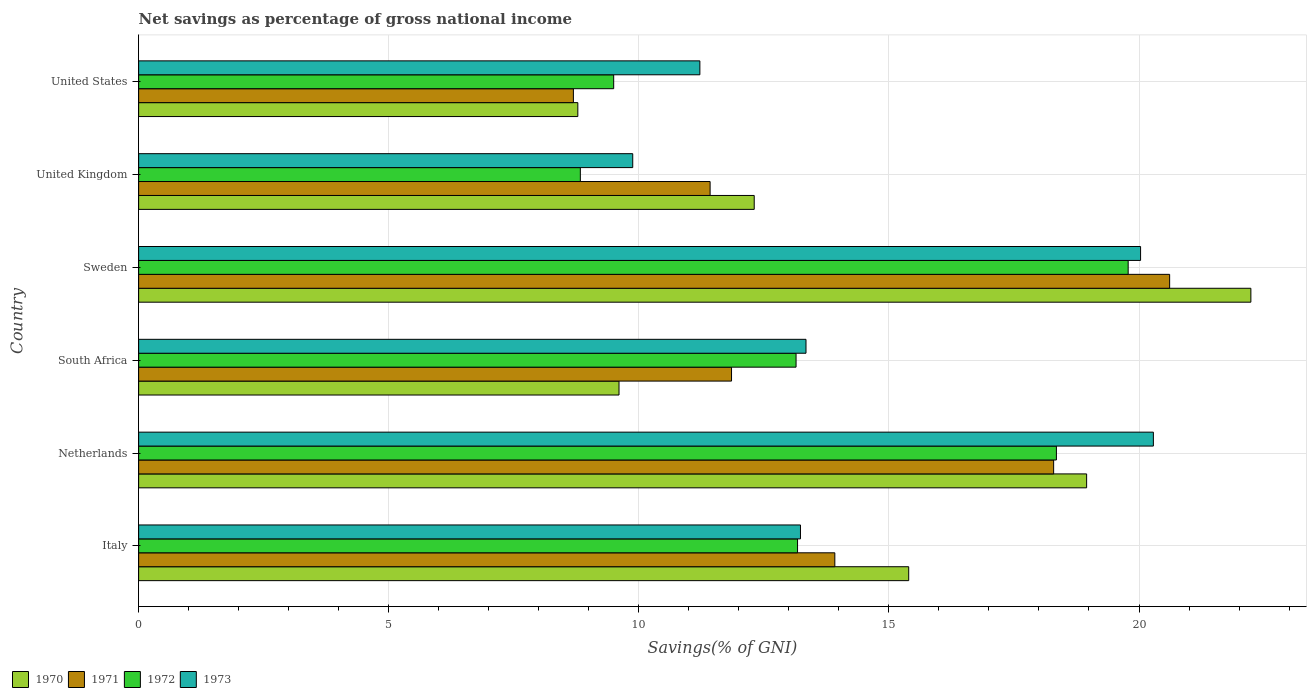How many different coloured bars are there?
Provide a short and direct response. 4. How many groups of bars are there?
Your answer should be compact. 6. Are the number of bars per tick equal to the number of legend labels?
Give a very brief answer. Yes. How many bars are there on the 6th tick from the bottom?
Make the answer very short. 4. What is the label of the 1st group of bars from the top?
Your answer should be compact. United States. In how many cases, is the number of bars for a given country not equal to the number of legend labels?
Make the answer very short. 0. What is the total savings in 1972 in United States?
Your answer should be very brief. 9.5. Across all countries, what is the maximum total savings in 1970?
Your answer should be very brief. 22.24. Across all countries, what is the minimum total savings in 1971?
Provide a short and direct response. 8.69. In which country was the total savings in 1971 maximum?
Your response must be concise. Sweden. What is the total total savings in 1971 in the graph?
Provide a succinct answer. 84.8. What is the difference between the total savings in 1971 in Netherlands and that in United States?
Make the answer very short. 9.6. What is the difference between the total savings in 1973 in United States and the total savings in 1972 in United Kingdom?
Provide a short and direct response. 2.39. What is the average total savings in 1971 per country?
Your answer should be compact. 14.13. What is the difference between the total savings in 1971 and total savings in 1972 in South Africa?
Your answer should be very brief. -1.29. What is the ratio of the total savings in 1971 in Sweden to that in United States?
Your answer should be very brief. 2.37. Is the difference between the total savings in 1971 in South Africa and United Kingdom greater than the difference between the total savings in 1972 in South Africa and United Kingdom?
Your answer should be compact. No. What is the difference between the highest and the second highest total savings in 1971?
Your answer should be compact. 2.32. What is the difference between the highest and the lowest total savings in 1972?
Offer a very short reply. 10.95. In how many countries, is the total savings in 1971 greater than the average total savings in 1971 taken over all countries?
Ensure brevity in your answer.  2. Is it the case that in every country, the sum of the total savings in 1970 and total savings in 1972 is greater than the sum of total savings in 1971 and total savings in 1973?
Your answer should be compact. No. What does the 2nd bar from the top in Italy represents?
Offer a very short reply. 1972. How many bars are there?
Provide a short and direct response. 24. Are the values on the major ticks of X-axis written in scientific E-notation?
Offer a terse response. No. Where does the legend appear in the graph?
Make the answer very short. Bottom left. How many legend labels are there?
Your answer should be very brief. 4. How are the legend labels stacked?
Your answer should be compact. Horizontal. What is the title of the graph?
Your response must be concise. Net savings as percentage of gross national income. Does "1961" appear as one of the legend labels in the graph?
Provide a succinct answer. No. What is the label or title of the X-axis?
Ensure brevity in your answer.  Savings(% of GNI). What is the Savings(% of GNI) of 1970 in Italy?
Offer a very short reply. 15.4. What is the Savings(% of GNI) in 1971 in Italy?
Your answer should be compact. 13.92. What is the Savings(% of GNI) in 1972 in Italy?
Offer a terse response. 13.17. What is the Savings(% of GNI) in 1973 in Italy?
Keep it short and to the point. 13.23. What is the Savings(% of GNI) of 1970 in Netherlands?
Your answer should be compact. 18.95. What is the Savings(% of GNI) of 1971 in Netherlands?
Ensure brevity in your answer.  18.29. What is the Savings(% of GNI) of 1972 in Netherlands?
Your answer should be compact. 18.35. What is the Savings(% of GNI) in 1973 in Netherlands?
Your answer should be very brief. 20.29. What is the Savings(% of GNI) of 1970 in South Africa?
Your answer should be very brief. 9.6. What is the Savings(% of GNI) of 1971 in South Africa?
Ensure brevity in your answer.  11.85. What is the Savings(% of GNI) in 1972 in South Africa?
Offer a terse response. 13.14. What is the Savings(% of GNI) in 1973 in South Africa?
Your response must be concise. 13.34. What is the Savings(% of GNI) of 1970 in Sweden?
Provide a short and direct response. 22.24. What is the Savings(% of GNI) in 1971 in Sweden?
Your answer should be compact. 20.61. What is the Savings(% of GNI) in 1972 in Sweden?
Your answer should be compact. 19.78. What is the Savings(% of GNI) of 1973 in Sweden?
Make the answer very short. 20.03. What is the Savings(% of GNI) in 1970 in United Kingdom?
Provide a succinct answer. 12.31. What is the Savings(% of GNI) in 1971 in United Kingdom?
Your answer should be compact. 11.43. What is the Savings(% of GNI) in 1972 in United Kingdom?
Your response must be concise. 8.83. What is the Savings(% of GNI) of 1973 in United Kingdom?
Ensure brevity in your answer.  9.88. What is the Savings(% of GNI) of 1970 in United States?
Ensure brevity in your answer.  8.78. What is the Savings(% of GNI) in 1971 in United States?
Your answer should be compact. 8.69. What is the Savings(% of GNI) in 1972 in United States?
Your response must be concise. 9.5. What is the Savings(% of GNI) in 1973 in United States?
Provide a succinct answer. 11.22. Across all countries, what is the maximum Savings(% of GNI) of 1970?
Your answer should be compact. 22.24. Across all countries, what is the maximum Savings(% of GNI) of 1971?
Provide a succinct answer. 20.61. Across all countries, what is the maximum Savings(% of GNI) in 1972?
Ensure brevity in your answer.  19.78. Across all countries, what is the maximum Savings(% of GNI) in 1973?
Your response must be concise. 20.29. Across all countries, what is the minimum Savings(% of GNI) of 1970?
Your answer should be compact. 8.78. Across all countries, what is the minimum Savings(% of GNI) in 1971?
Give a very brief answer. 8.69. Across all countries, what is the minimum Savings(% of GNI) of 1972?
Your answer should be very brief. 8.83. Across all countries, what is the minimum Savings(% of GNI) of 1973?
Ensure brevity in your answer.  9.88. What is the total Savings(% of GNI) of 1970 in the graph?
Your answer should be very brief. 87.28. What is the total Savings(% of GNI) in 1971 in the graph?
Keep it short and to the point. 84.8. What is the total Savings(% of GNI) in 1972 in the graph?
Your response must be concise. 82.78. What is the total Savings(% of GNI) of 1973 in the graph?
Your answer should be compact. 87.99. What is the difference between the Savings(% of GNI) of 1970 in Italy and that in Netherlands?
Offer a very short reply. -3.56. What is the difference between the Savings(% of GNI) of 1971 in Italy and that in Netherlands?
Give a very brief answer. -4.37. What is the difference between the Savings(% of GNI) of 1972 in Italy and that in Netherlands?
Provide a succinct answer. -5.18. What is the difference between the Savings(% of GNI) in 1973 in Italy and that in Netherlands?
Your answer should be compact. -7.06. What is the difference between the Savings(% of GNI) of 1970 in Italy and that in South Africa?
Provide a short and direct response. 5.79. What is the difference between the Savings(% of GNI) in 1971 in Italy and that in South Africa?
Give a very brief answer. 2.07. What is the difference between the Savings(% of GNI) in 1972 in Italy and that in South Africa?
Your answer should be compact. 0.03. What is the difference between the Savings(% of GNI) in 1973 in Italy and that in South Africa?
Provide a short and direct response. -0.11. What is the difference between the Savings(% of GNI) in 1970 in Italy and that in Sweden?
Ensure brevity in your answer.  -6.84. What is the difference between the Savings(% of GNI) in 1971 in Italy and that in Sweden?
Your answer should be compact. -6.69. What is the difference between the Savings(% of GNI) of 1972 in Italy and that in Sweden?
Offer a very short reply. -6.61. What is the difference between the Savings(% of GNI) in 1973 in Italy and that in Sweden?
Make the answer very short. -6.8. What is the difference between the Savings(% of GNI) of 1970 in Italy and that in United Kingdom?
Keep it short and to the point. 3.09. What is the difference between the Savings(% of GNI) in 1971 in Italy and that in United Kingdom?
Your response must be concise. 2.49. What is the difference between the Savings(% of GNI) of 1972 in Italy and that in United Kingdom?
Your answer should be compact. 4.34. What is the difference between the Savings(% of GNI) in 1973 in Italy and that in United Kingdom?
Offer a very short reply. 3.35. What is the difference between the Savings(% of GNI) of 1970 in Italy and that in United States?
Offer a terse response. 6.62. What is the difference between the Savings(% of GNI) in 1971 in Italy and that in United States?
Make the answer very short. 5.23. What is the difference between the Savings(% of GNI) of 1972 in Italy and that in United States?
Ensure brevity in your answer.  3.68. What is the difference between the Savings(% of GNI) of 1973 in Italy and that in United States?
Your answer should be very brief. 2.01. What is the difference between the Savings(% of GNI) of 1970 in Netherlands and that in South Africa?
Ensure brevity in your answer.  9.35. What is the difference between the Savings(% of GNI) in 1971 in Netherlands and that in South Africa?
Keep it short and to the point. 6.44. What is the difference between the Savings(% of GNI) of 1972 in Netherlands and that in South Africa?
Provide a short and direct response. 5.21. What is the difference between the Savings(% of GNI) of 1973 in Netherlands and that in South Africa?
Your response must be concise. 6.95. What is the difference between the Savings(% of GNI) of 1970 in Netherlands and that in Sweden?
Ensure brevity in your answer.  -3.28. What is the difference between the Savings(% of GNI) in 1971 in Netherlands and that in Sweden?
Keep it short and to the point. -2.32. What is the difference between the Savings(% of GNI) of 1972 in Netherlands and that in Sweden?
Your answer should be very brief. -1.43. What is the difference between the Savings(% of GNI) of 1973 in Netherlands and that in Sweden?
Offer a very short reply. 0.26. What is the difference between the Savings(% of GNI) in 1970 in Netherlands and that in United Kingdom?
Provide a succinct answer. 6.65. What is the difference between the Savings(% of GNI) of 1971 in Netherlands and that in United Kingdom?
Give a very brief answer. 6.87. What is the difference between the Savings(% of GNI) of 1972 in Netherlands and that in United Kingdom?
Your answer should be very brief. 9.52. What is the difference between the Savings(% of GNI) of 1973 in Netherlands and that in United Kingdom?
Make the answer very short. 10.41. What is the difference between the Savings(% of GNI) of 1970 in Netherlands and that in United States?
Give a very brief answer. 10.17. What is the difference between the Savings(% of GNI) in 1971 in Netherlands and that in United States?
Provide a succinct answer. 9.6. What is the difference between the Savings(% of GNI) in 1972 in Netherlands and that in United States?
Ensure brevity in your answer.  8.85. What is the difference between the Savings(% of GNI) in 1973 in Netherlands and that in United States?
Your answer should be compact. 9.07. What is the difference between the Savings(% of GNI) of 1970 in South Africa and that in Sweden?
Keep it short and to the point. -12.63. What is the difference between the Savings(% of GNI) of 1971 in South Africa and that in Sweden?
Provide a short and direct response. -8.76. What is the difference between the Savings(% of GNI) in 1972 in South Africa and that in Sweden?
Your answer should be compact. -6.64. What is the difference between the Savings(% of GNI) of 1973 in South Africa and that in Sweden?
Your response must be concise. -6.69. What is the difference between the Savings(% of GNI) of 1970 in South Africa and that in United Kingdom?
Offer a very short reply. -2.7. What is the difference between the Savings(% of GNI) in 1971 in South Africa and that in United Kingdom?
Your answer should be very brief. 0.43. What is the difference between the Savings(% of GNI) in 1972 in South Africa and that in United Kingdom?
Keep it short and to the point. 4.31. What is the difference between the Savings(% of GNI) of 1973 in South Africa and that in United Kingdom?
Your answer should be compact. 3.46. What is the difference between the Savings(% of GNI) in 1970 in South Africa and that in United States?
Your response must be concise. 0.82. What is the difference between the Savings(% of GNI) of 1971 in South Africa and that in United States?
Offer a very short reply. 3.16. What is the difference between the Savings(% of GNI) in 1972 in South Africa and that in United States?
Your answer should be very brief. 3.65. What is the difference between the Savings(% of GNI) in 1973 in South Africa and that in United States?
Your response must be concise. 2.12. What is the difference between the Savings(% of GNI) of 1970 in Sweden and that in United Kingdom?
Your answer should be compact. 9.93. What is the difference between the Savings(% of GNI) in 1971 in Sweden and that in United Kingdom?
Provide a short and direct response. 9.19. What is the difference between the Savings(% of GNI) of 1972 in Sweden and that in United Kingdom?
Your answer should be very brief. 10.95. What is the difference between the Savings(% of GNI) of 1973 in Sweden and that in United Kingdom?
Your answer should be compact. 10.15. What is the difference between the Savings(% of GNI) of 1970 in Sweden and that in United States?
Ensure brevity in your answer.  13.46. What is the difference between the Savings(% of GNI) in 1971 in Sweden and that in United States?
Provide a short and direct response. 11.92. What is the difference between the Savings(% of GNI) in 1972 in Sweden and that in United States?
Provide a short and direct response. 10.29. What is the difference between the Savings(% of GNI) of 1973 in Sweden and that in United States?
Offer a terse response. 8.81. What is the difference between the Savings(% of GNI) in 1970 in United Kingdom and that in United States?
Make the answer very short. 3.53. What is the difference between the Savings(% of GNI) in 1971 in United Kingdom and that in United States?
Give a very brief answer. 2.73. What is the difference between the Savings(% of GNI) in 1972 in United Kingdom and that in United States?
Provide a short and direct response. -0.67. What is the difference between the Savings(% of GNI) in 1973 in United Kingdom and that in United States?
Make the answer very short. -1.34. What is the difference between the Savings(% of GNI) in 1970 in Italy and the Savings(% of GNI) in 1971 in Netherlands?
Provide a succinct answer. -2.9. What is the difference between the Savings(% of GNI) of 1970 in Italy and the Savings(% of GNI) of 1972 in Netherlands?
Ensure brevity in your answer.  -2.95. What is the difference between the Savings(% of GNI) of 1970 in Italy and the Savings(% of GNI) of 1973 in Netherlands?
Give a very brief answer. -4.89. What is the difference between the Savings(% of GNI) in 1971 in Italy and the Savings(% of GNI) in 1972 in Netherlands?
Provide a succinct answer. -4.43. What is the difference between the Savings(% of GNI) of 1971 in Italy and the Savings(% of GNI) of 1973 in Netherlands?
Your answer should be compact. -6.37. What is the difference between the Savings(% of GNI) of 1972 in Italy and the Savings(% of GNI) of 1973 in Netherlands?
Your answer should be very brief. -7.11. What is the difference between the Savings(% of GNI) in 1970 in Italy and the Savings(% of GNI) in 1971 in South Africa?
Provide a short and direct response. 3.54. What is the difference between the Savings(% of GNI) of 1970 in Italy and the Savings(% of GNI) of 1972 in South Africa?
Offer a very short reply. 2.25. What is the difference between the Savings(% of GNI) of 1970 in Italy and the Savings(% of GNI) of 1973 in South Africa?
Provide a short and direct response. 2.05. What is the difference between the Savings(% of GNI) of 1971 in Italy and the Savings(% of GNI) of 1972 in South Africa?
Offer a very short reply. 0.78. What is the difference between the Savings(% of GNI) of 1971 in Italy and the Savings(% of GNI) of 1973 in South Africa?
Offer a very short reply. 0.58. What is the difference between the Savings(% of GNI) in 1972 in Italy and the Savings(% of GNI) in 1973 in South Africa?
Make the answer very short. -0.17. What is the difference between the Savings(% of GNI) in 1970 in Italy and the Savings(% of GNI) in 1971 in Sweden?
Offer a very short reply. -5.22. What is the difference between the Savings(% of GNI) in 1970 in Italy and the Savings(% of GNI) in 1972 in Sweden?
Your answer should be compact. -4.39. What is the difference between the Savings(% of GNI) in 1970 in Italy and the Savings(% of GNI) in 1973 in Sweden?
Make the answer very short. -4.64. What is the difference between the Savings(% of GNI) in 1971 in Italy and the Savings(% of GNI) in 1972 in Sweden?
Offer a terse response. -5.86. What is the difference between the Savings(% of GNI) in 1971 in Italy and the Savings(% of GNI) in 1973 in Sweden?
Your answer should be compact. -6.11. What is the difference between the Savings(% of GNI) in 1972 in Italy and the Savings(% of GNI) in 1973 in Sweden?
Keep it short and to the point. -6.86. What is the difference between the Savings(% of GNI) of 1970 in Italy and the Savings(% of GNI) of 1971 in United Kingdom?
Offer a very short reply. 3.97. What is the difference between the Savings(% of GNI) in 1970 in Italy and the Savings(% of GNI) in 1972 in United Kingdom?
Ensure brevity in your answer.  6.56. What is the difference between the Savings(% of GNI) of 1970 in Italy and the Savings(% of GNI) of 1973 in United Kingdom?
Provide a short and direct response. 5.52. What is the difference between the Savings(% of GNI) of 1971 in Italy and the Savings(% of GNI) of 1972 in United Kingdom?
Your response must be concise. 5.09. What is the difference between the Savings(% of GNI) in 1971 in Italy and the Savings(% of GNI) in 1973 in United Kingdom?
Your answer should be compact. 4.04. What is the difference between the Savings(% of GNI) in 1972 in Italy and the Savings(% of GNI) in 1973 in United Kingdom?
Offer a very short reply. 3.3. What is the difference between the Savings(% of GNI) in 1970 in Italy and the Savings(% of GNI) in 1971 in United States?
Your response must be concise. 6.7. What is the difference between the Savings(% of GNI) of 1970 in Italy and the Savings(% of GNI) of 1972 in United States?
Provide a succinct answer. 5.9. What is the difference between the Savings(% of GNI) in 1970 in Italy and the Savings(% of GNI) in 1973 in United States?
Give a very brief answer. 4.17. What is the difference between the Savings(% of GNI) in 1971 in Italy and the Savings(% of GNI) in 1972 in United States?
Your response must be concise. 4.42. What is the difference between the Savings(% of GNI) of 1971 in Italy and the Savings(% of GNI) of 1973 in United States?
Your response must be concise. 2.7. What is the difference between the Savings(% of GNI) in 1972 in Italy and the Savings(% of GNI) in 1973 in United States?
Offer a very short reply. 1.95. What is the difference between the Savings(% of GNI) of 1970 in Netherlands and the Savings(% of GNI) of 1971 in South Africa?
Ensure brevity in your answer.  7.1. What is the difference between the Savings(% of GNI) of 1970 in Netherlands and the Savings(% of GNI) of 1972 in South Africa?
Give a very brief answer. 5.81. What is the difference between the Savings(% of GNI) in 1970 in Netherlands and the Savings(% of GNI) in 1973 in South Africa?
Keep it short and to the point. 5.61. What is the difference between the Savings(% of GNI) of 1971 in Netherlands and the Savings(% of GNI) of 1972 in South Africa?
Make the answer very short. 5.15. What is the difference between the Savings(% of GNI) of 1971 in Netherlands and the Savings(% of GNI) of 1973 in South Africa?
Ensure brevity in your answer.  4.95. What is the difference between the Savings(% of GNI) in 1972 in Netherlands and the Savings(% of GNI) in 1973 in South Africa?
Your answer should be very brief. 5.01. What is the difference between the Savings(% of GNI) of 1970 in Netherlands and the Savings(% of GNI) of 1971 in Sweden?
Give a very brief answer. -1.66. What is the difference between the Savings(% of GNI) in 1970 in Netherlands and the Savings(% of GNI) in 1972 in Sweden?
Offer a terse response. -0.83. What is the difference between the Savings(% of GNI) of 1970 in Netherlands and the Savings(% of GNI) of 1973 in Sweden?
Give a very brief answer. -1.08. What is the difference between the Savings(% of GNI) of 1971 in Netherlands and the Savings(% of GNI) of 1972 in Sweden?
Offer a very short reply. -1.49. What is the difference between the Savings(% of GNI) in 1971 in Netherlands and the Savings(% of GNI) in 1973 in Sweden?
Offer a terse response. -1.74. What is the difference between the Savings(% of GNI) in 1972 in Netherlands and the Savings(% of GNI) in 1973 in Sweden?
Your answer should be compact. -1.68. What is the difference between the Savings(% of GNI) of 1970 in Netherlands and the Savings(% of GNI) of 1971 in United Kingdom?
Make the answer very short. 7.53. What is the difference between the Savings(% of GNI) of 1970 in Netherlands and the Savings(% of GNI) of 1972 in United Kingdom?
Provide a short and direct response. 10.12. What is the difference between the Savings(% of GNI) in 1970 in Netherlands and the Savings(% of GNI) in 1973 in United Kingdom?
Your answer should be very brief. 9.07. What is the difference between the Savings(% of GNI) in 1971 in Netherlands and the Savings(% of GNI) in 1972 in United Kingdom?
Make the answer very short. 9.46. What is the difference between the Savings(% of GNI) in 1971 in Netherlands and the Savings(% of GNI) in 1973 in United Kingdom?
Your answer should be compact. 8.42. What is the difference between the Savings(% of GNI) of 1972 in Netherlands and the Savings(% of GNI) of 1973 in United Kingdom?
Your response must be concise. 8.47. What is the difference between the Savings(% of GNI) of 1970 in Netherlands and the Savings(% of GNI) of 1971 in United States?
Your answer should be compact. 10.26. What is the difference between the Savings(% of GNI) in 1970 in Netherlands and the Savings(% of GNI) in 1972 in United States?
Your answer should be very brief. 9.46. What is the difference between the Savings(% of GNI) in 1970 in Netherlands and the Savings(% of GNI) in 1973 in United States?
Ensure brevity in your answer.  7.73. What is the difference between the Savings(% of GNI) of 1971 in Netherlands and the Savings(% of GNI) of 1972 in United States?
Make the answer very short. 8.8. What is the difference between the Savings(% of GNI) in 1971 in Netherlands and the Savings(% of GNI) in 1973 in United States?
Give a very brief answer. 7.07. What is the difference between the Savings(% of GNI) in 1972 in Netherlands and the Savings(% of GNI) in 1973 in United States?
Your answer should be very brief. 7.13. What is the difference between the Savings(% of GNI) in 1970 in South Africa and the Savings(% of GNI) in 1971 in Sweden?
Ensure brevity in your answer.  -11.01. What is the difference between the Savings(% of GNI) in 1970 in South Africa and the Savings(% of GNI) in 1972 in Sweden?
Keep it short and to the point. -10.18. What is the difference between the Savings(% of GNI) of 1970 in South Africa and the Savings(% of GNI) of 1973 in Sweden?
Ensure brevity in your answer.  -10.43. What is the difference between the Savings(% of GNI) in 1971 in South Africa and the Savings(% of GNI) in 1972 in Sweden?
Provide a short and direct response. -7.93. What is the difference between the Savings(% of GNI) of 1971 in South Africa and the Savings(% of GNI) of 1973 in Sweden?
Your answer should be compact. -8.18. What is the difference between the Savings(% of GNI) of 1972 in South Africa and the Savings(% of GNI) of 1973 in Sweden?
Your answer should be very brief. -6.89. What is the difference between the Savings(% of GNI) in 1970 in South Africa and the Savings(% of GNI) in 1971 in United Kingdom?
Provide a succinct answer. -1.82. What is the difference between the Savings(% of GNI) in 1970 in South Africa and the Savings(% of GNI) in 1972 in United Kingdom?
Offer a terse response. 0.77. What is the difference between the Savings(% of GNI) in 1970 in South Africa and the Savings(% of GNI) in 1973 in United Kingdom?
Provide a short and direct response. -0.27. What is the difference between the Savings(% of GNI) of 1971 in South Africa and the Savings(% of GNI) of 1972 in United Kingdom?
Keep it short and to the point. 3.02. What is the difference between the Savings(% of GNI) of 1971 in South Africa and the Savings(% of GNI) of 1973 in United Kingdom?
Your answer should be compact. 1.98. What is the difference between the Savings(% of GNI) in 1972 in South Africa and the Savings(% of GNI) in 1973 in United Kingdom?
Ensure brevity in your answer.  3.27. What is the difference between the Savings(% of GNI) in 1970 in South Africa and the Savings(% of GNI) in 1971 in United States?
Ensure brevity in your answer.  0.91. What is the difference between the Savings(% of GNI) of 1970 in South Africa and the Savings(% of GNI) of 1972 in United States?
Offer a terse response. 0.11. What is the difference between the Savings(% of GNI) in 1970 in South Africa and the Savings(% of GNI) in 1973 in United States?
Provide a short and direct response. -1.62. What is the difference between the Savings(% of GNI) in 1971 in South Africa and the Savings(% of GNI) in 1972 in United States?
Your answer should be very brief. 2.36. What is the difference between the Savings(% of GNI) of 1971 in South Africa and the Savings(% of GNI) of 1973 in United States?
Offer a terse response. 0.63. What is the difference between the Savings(% of GNI) of 1972 in South Africa and the Savings(% of GNI) of 1973 in United States?
Offer a terse response. 1.92. What is the difference between the Savings(% of GNI) in 1970 in Sweden and the Savings(% of GNI) in 1971 in United Kingdom?
Ensure brevity in your answer.  10.81. What is the difference between the Savings(% of GNI) of 1970 in Sweden and the Savings(% of GNI) of 1972 in United Kingdom?
Give a very brief answer. 13.41. What is the difference between the Savings(% of GNI) in 1970 in Sweden and the Savings(% of GNI) in 1973 in United Kingdom?
Provide a succinct answer. 12.36. What is the difference between the Savings(% of GNI) of 1971 in Sweden and the Savings(% of GNI) of 1972 in United Kingdom?
Your answer should be compact. 11.78. What is the difference between the Savings(% of GNI) of 1971 in Sweden and the Savings(% of GNI) of 1973 in United Kingdom?
Provide a short and direct response. 10.73. What is the difference between the Savings(% of GNI) of 1972 in Sweden and the Savings(% of GNI) of 1973 in United Kingdom?
Your answer should be compact. 9.91. What is the difference between the Savings(% of GNI) in 1970 in Sweden and the Savings(% of GNI) in 1971 in United States?
Ensure brevity in your answer.  13.54. What is the difference between the Savings(% of GNI) of 1970 in Sweden and the Savings(% of GNI) of 1972 in United States?
Ensure brevity in your answer.  12.74. What is the difference between the Savings(% of GNI) in 1970 in Sweden and the Savings(% of GNI) in 1973 in United States?
Ensure brevity in your answer.  11.02. What is the difference between the Savings(% of GNI) of 1971 in Sweden and the Savings(% of GNI) of 1972 in United States?
Make the answer very short. 11.12. What is the difference between the Savings(% of GNI) of 1971 in Sweden and the Savings(% of GNI) of 1973 in United States?
Ensure brevity in your answer.  9.39. What is the difference between the Savings(% of GNI) in 1972 in Sweden and the Savings(% of GNI) in 1973 in United States?
Provide a succinct answer. 8.56. What is the difference between the Savings(% of GNI) in 1970 in United Kingdom and the Savings(% of GNI) in 1971 in United States?
Offer a terse response. 3.62. What is the difference between the Savings(% of GNI) in 1970 in United Kingdom and the Savings(% of GNI) in 1972 in United States?
Offer a very short reply. 2.81. What is the difference between the Savings(% of GNI) of 1970 in United Kingdom and the Savings(% of GNI) of 1973 in United States?
Offer a very short reply. 1.09. What is the difference between the Savings(% of GNI) of 1971 in United Kingdom and the Savings(% of GNI) of 1972 in United States?
Provide a short and direct response. 1.93. What is the difference between the Savings(% of GNI) of 1971 in United Kingdom and the Savings(% of GNI) of 1973 in United States?
Your answer should be compact. 0.2. What is the difference between the Savings(% of GNI) in 1972 in United Kingdom and the Savings(% of GNI) in 1973 in United States?
Your response must be concise. -2.39. What is the average Savings(% of GNI) in 1970 per country?
Give a very brief answer. 14.55. What is the average Savings(% of GNI) of 1971 per country?
Offer a terse response. 14.13. What is the average Savings(% of GNI) of 1972 per country?
Offer a very short reply. 13.8. What is the average Savings(% of GNI) of 1973 per country?
Your answer should be compact. 14.67. What is the difference between the Savings(% of GNI) in 1970 and Savings(% of GNI) in 1971 in Italy?
Your response must be concise. 1.48. What is the difference between the Savings(% of GNI) in 1970 and Savings(% of GNI) in 1972 in Italy?
Provide a short and direct response. 2.22. What is the difference between the Savings(% of GNI) in 1970 and Savings(% of GNI) in 1973 in Italy?
Your answer should be very brief. 2.16. What is the difference between the Savings(% of GNI) of 1971 and Savings(% of GNI) of 1972 in Italy?
Keep it short and to the point. 0.75. What is the difference between the Savings(% of GNI) of 1971 and Savings(% of GNI) of 1973 in Italy?
Give a very brief answer. 0.69. What is the difference between the Savings(% of GNI) of 1972 and Savings(% of GNI) of 1973 in Italy?
Your answer should be very brief. -0.06. What is the difference between the Savings(% of GNI) in 1970 and Savings(% of GNI) in 1971 in Netherlands?
Keep it short and to the point. 0.66. What is the difference between the Savings(% of GNI) in 1970 and Savings(% of GNI) in 1972 in Netherlands?
Ensure brevity in your answer.  0.6. What is the difference between the Savings(% of GNI) in 1970 and Savings(% of GNI) in 1973 in Netherlands?
Provide a short and direct response. -1.33. What is the difference between the Savings(% of GNI) of 1971 and Savings(% of GNI) of 1972 in Netherlands?
Offer a very short reply. -0.06. What is the difference between the Savings(% of GNI) of 1971 and Savings(% of GNI) of 1973 in Netherlands?
Give a very brief answer. -1.99. What is the difference between the Savings(% of GNI) of 1972 and Savings(% of GNI) of 1973 in Netherlands?
Ensure brevity in your answer.  -1.94. What is the difference between the Savings(% of GNI) in 1970 and Savings(% of GNI) in 1971 in South Africa?
Offer a very short reply. -2.25. What is the difference between the Savings(% of GNI) of 1970 and Savings(% of GNI) of 1972 in South Africa?
Offer a terse response. -3.54. What is the difference between the Savings(% of GNI) of 1970 and Savings(% of GNI) of 1973 in South Africa?
Your response must be concise. -3.74. What is the difference between the Savings(% of GNI) in 1971 and Savings(% of GNI) in 1972 in South Africa?
Offer a terse response. -1.29. What is the difference between the Savings(% of GNI) in 1971 and Savings(% of GNI) in 1973 in South Africa?
Your response must be concise. -1.49. What is the difference between the Savings(% of GNI) in 1972 and Savings(% of GNI) in 1973 in South Africa?
Keep it short and to the point. -0.2. What is the difference between the Savings(% of GNI) in 1970 and Savings(% of GNI) in 1971 in Sweden?
Give a very brief answer. 1.62. What is the difference between the Savings(% of GNI) in 1970 and Savings(% of GNI) in 1972 in Sweden?
Make the answer very short. 2.45. What is the difference between the Savings(% of GNI) in 1970 and Savings(% of GNI) in 1973 in Sweden?
Provide a short and direct response. 2.21. What is the difference between the Savings(% of GNI) of 1971 and Savings(% of GNI) of 1972 in Sweden?
Offer a very short reply. 0.83. What is the difference between the Savings(% of GNI) in 1971 and Savings(% of GNI) in 1973 in Sweden?
Ensure brevity in your answer.  0.58. What is the difference between the Savings(% of GNI) in 1972 and Savings(% of GNI) in 1973 in Sweden?
Offer a terse response. -0.25. What is the difference between the Savings(% of GNI) in 1970 and Savings(% of GNI) in 1971 in United Kingdom?
Provide a short and direct response. 0.88. What is the difference between the Savings(% of GNI) of 1970 and Savings(% of GNI) of 1972 in United Kingdom?
Provide a succinct answer. 3.48. What is the difference between the Savings(% of GNI) in 1970 and Savings(% of GNI) in 1973 in United Kingdom?
Make the answer very short. 2.43. What is the difference between the Savings(% of GNI) in 1971 and Savings(% of GNI) in 1972 in United Kingdom?
Keep it short and to the point. 2.59. What is the difference between the Savings(% of GNI) in 1971 and Savings(% of GNI) in 1973 in United Kingdom?
Make the answer very short. 1.55. What is the difference between the Savings(% of GNI) of 1972 and Savings(% of GNI) of 1973 in United Kingdom?
Ensure brevity in your answer.  -1.05. What is the difference between the Savings(% of GNI) of 1970 and Savings(% of GNI) of 1971 in United States?
Your response must be concise. 0.09. What is the difference between the Savings(% of GNI) in 1970 and Savings(% of GNI) in 1972 in United States?
Provide a short and direct response. -0.72. What is the difference between the Savings(% of GNI) of 1970 and Savings(% of GNI) of 1973 in United States?
Offer a terse response. -2.44. What is the difference between the Savings(% of GNI) in 1971 and Savings(% of GNI) in 1972 in United States?
Ensure brevity in your answer.  -0.81. What is the difference between the Savings(% of GNI) in 1971 and Savings(% of GNI) in 1973 in United States?
Offer a terse response. -2.53. What is the difference between the Savings(% of GNI) of 1972 and Savings(% of GNI) of 1973 in United States?
Give a very brief answer. -1.72. What is the ratio of the Savings(% of GNI) in 1970 in Italy to that in Netherlands?
Your response must be concise. 0.81. What is the ratio of the Savings(% of GNI) in 1971 in Italy to that in Netherlands?
Keep it short and to the point. 0.76. What is the ratio of the Savings(% of GNI) in 1972 in Italy to that in Netherlands?
Give a very brief answer. 0.72. What is the ratio of the Savings(% of GNI) in 1973 in Italy to that in Netherlands?
Ensure brevity in your answer.  0.65. What is the ratio of the Savings(% of GNI) of 1970 in Italy to that in South Africa?
Ensure brevity in your answer.  1.6. What is the ratio of the Savings(% of GNI) in 1971 in Italy to that in South Africa?
Provide a succinct answer. 1.17. What is the ratio of the Savings(% of GNI) of 1970 in Italy to that in Sweden?
Offer a terse response. 0.69. What is the ratio of the Savings(% of GNI) of 1971 in Italy to that in Sweden?
Offer a terse response. 0.68. What is the ratio of the Savings(% of GNI) of 1972 in Italy to that in Sweden?
Offer a very short reply. 0.67. What is the ratio of the Savings(% of GNI) in 1973 in Italy to that in Sweden?
Ensure brevity in your answer.  0.66. What is the ratio of the Savings(% of GNI) of 1970 in Italy to that in United Kingdom?
Your answer should be compact. 1.25. What is the ratio of the Savings(% of GNI) of 1971 in Italy to that in United Kingdom?
Give a very brief answer. 1.22. What is the ratio of the Savings(% of GNI) in 1972 in Italy to that in United Kingdom?
Offer a very short reply. 1.49. What is the ratio of the Savings(% of GNI) of 1973 in Italy to that in United Kingdom?
Provide a succinct answer. 1.34. What is the ratio of the Savings(% of GNI) of 1970 in Italy to that in United States?
Offer a very short reply. 1.75. What is the ratio of the Savings(% of GNI) of 1971 in Italy to that in United States?
Your answer should be very brief. 1.6. What is the ratio of the Savings(% of GNI) of 1972 in Italy to that in United States?
Give a very brief answer. 1.39. What is the ratio of the Savings(% of GNI) in 1973 in Italy to that in United States?
Keep it short and to the point. 1.18. What is the ratio of the Savings(% of GNI) of 1970 in Netherlands to that in South Africa?
Offer a terse response. 1.97. What is the ratio of the Savings(% of GNI) of 1971 in Netherlands to that in South Africa?
Provide a succinct answer. 1.54. What is the ratio of the Savings(% of GNI) of 1972 in Netherlands to that in South Africa?
Your response must be concise. 1.4. What is the ratio of the Savings(% of GNI) in 1973 in Netherlands to that in South Africa?
Your response must be concise. 1.52. What is the ratio of the Savings(% of GNI) in 1970 in Netherlands to that in Sweden?
Offer a very short reply. 0.85. What is the ratio of the Savings(% of GNI) of 1971 in Netherlands to that in Sweden?
Keep it short and to the point. 0.89. What is the ratio of the Savings(% of GNI) in 1972 in Netherlands to that in Sweden?
Your answer should be compact. 0.93. What is the ratio of the Savings(% of GNI) in 1973 in Netherlands to that in Sweden?
Offer a very short reply. 1.01. What is the ratio of the Savings(% of GNI) of 1970 in Netherlands to that in United Kingdom?
Provide a succinct answer. 1.54. What is the ratio of the Savings(% of GNI) in 1971 in Netherlands to that in United Kingdom?
Your response must be concise. 1.6. What is the ratio of the Savings(% of GNI) in 1972 in Netherlands to that in United Kingdom?
Provide a short and direct response. 2.08. What is the ratio of the Savings(% of GNI) in 1973 in Netherlands to that in United Kingdom?
Your answer should be compact. 2.05. What is the ratio of the Savings(% of GNI) of 1970 in Netherlands to that in United States?
Ensure brevity in your answer.  2.16. What is the ratio of the Savings(% of GNI) in 1971 in Netherlands to that in United States?
Your answer should be very brief. 2.1. What is the ratio of the Savings(% of GNI) in 1972 in Netherlands to that in United States?
Ensure brevity in your answer.  1.93. What is the ratio of the Savings(% of GNI) in 1973 in Netherlands to that in United States?
Your response must be concise. 1.81. What is the ratio of the Savings(% of GNI) in 1970 in South Africa to that in Sweden?
Ensure brevity in your answer.  0.43. What is the ratio of the Savings(% of GNI) of 1971 in South Africa to that in Sweden?
Your answer should be very brief. 0.58. What is the ratio of the Savings(% of GNI) in 1972 in South Africa to that in Sweden?
Offer a very short reply. 0.66. What is the ratio of the Savings(% of GNI) of 1973 in South Africa to that in Sweden?
Keep it short and to the point. 0.67. What is the ratio of the Savings(% of GNI) in 1970 in South Africa to that in United Kingdom?
Provide a short and direct response. 0.78. What is the ratio of the Savings(% of GNI) of 1971 in South Africa to that in United Kingdom?
Your answer should be compact. 1.04. What is the ratio of the Savings(% of GNI) in 1972 in South Africa to that in United Kingdom?
Provide a short and direct response. 1.49. What is the ratio of the Savings(% of GNI) in 1973 in South Africa to that in United Kingdom?
Keep it short and to the point. 1.35. What is the ratio of the Savings(% of GNI) in 1970 in South Africa to that in United States?
Ensure brevity in your answer.  1.09. What is the ratio of the Savings(% of GNI) in 1971 in South Africa to that in United States?
Provide a succinct answer. 1.36. What is the ratio of the Savings(% of GNI) of 1972 in South Africa to that in United States?
Offer a terse response. 1.38. What is the ratio of the Savings(% of GNI) of 1973 in South Africa to that in United States?
Make the answer very short. 1.19. What is the ratio of the Savings(% of GNI) in 1970 in Sweden to that in United Kingdom?
Provide a short and direct response. 1.81. What is the ratio of the Savings(% of GNI) in 1971 in Sweden to that in United Kingdom?
Your answer should be very brief. 1.8. What is the ratio of the Savings(% of GNI) in 1972 in Sweden to that in United Kingdom?
Offer a terse response. 2.24. What is the ratio of the Savings(% of GNI) of 1973 in Sweden to that in United Kingdom?
Your response must be concise. 2.03. What is the ratio of the Savings(% of GNI) of 1970 in Sweden to that in United States?
Offer a very short reply. 2.53. What is the ratio of the Savings(% of GNI) in 1971 in Sweden to that in United States?
Provide a succinct answer. 2.37. What is the ratio of the Savings(% of GNI) in 1972 in Sweden to that in United States?
Give a very brief answer. 2.08. What is the ratio of the Savings(% of GNI) in 1973 in Sweden to that in United States?
Offer a very short reply. 1.79. What is the ratio of the Savings(% of GNI) of 1970 in United Kingdom to that in United States?
Provide a succinct answer. 1.4. What is the ratio of the Savings(% of GNI) in 1971 in United Kingdom to that in United States?
Your response must be concise. 1.31. What is the ratio of the Savings(% of GNI) in 1972 in United Kingdom to that in United States?
Offer a very short reply. 0.93. What is the ratio of the Savings(% of GNI) of 1973 in United Kingdom to that in United States?
Offer a very short reply. 0.88. What is the difference between the highest and the second highest Savings(% of GNI) of 1970?
Provide a short and direct response. 3.28. What is the difference between the highest and the second highest Savings(% of GNI) of 1971?
Offer a terse response. 2.32. What is the difference between the highest and the second highest Savings(% of GNI) of 1972?
Keep it short and to the point. 1.43. What is the difference between the highest and the second highest Savings(% of GNI) of 1973?
Ensure brevity in your answer.  0.26. What is the difference between the highest and the lowest Savings(% of GNI) of 1970?
Keep it short and to the point. 13.46. What is the difference between the highest and the lowest Savings(% of GNI) of 1971?
Offer a terse response. 11.92. What is the difference between the highest and the lowest Savings(% of GNI) of 1972?
Give a very brief answer. 10.95. What is the difference between the highest and the lowest Savings(% of GNI) of 1973?
Keep it short and to the point. 10.41. 